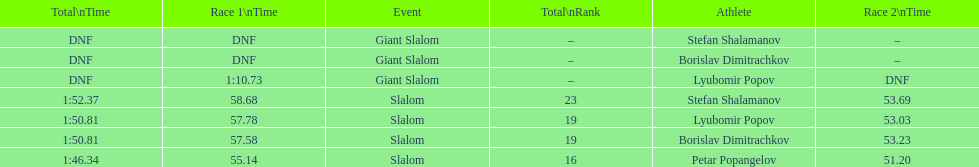Which athletes had consecutive times under 58 for both races? Lyubomir Popov, Borislav Dimitrachkov, Petar Popangelov. 